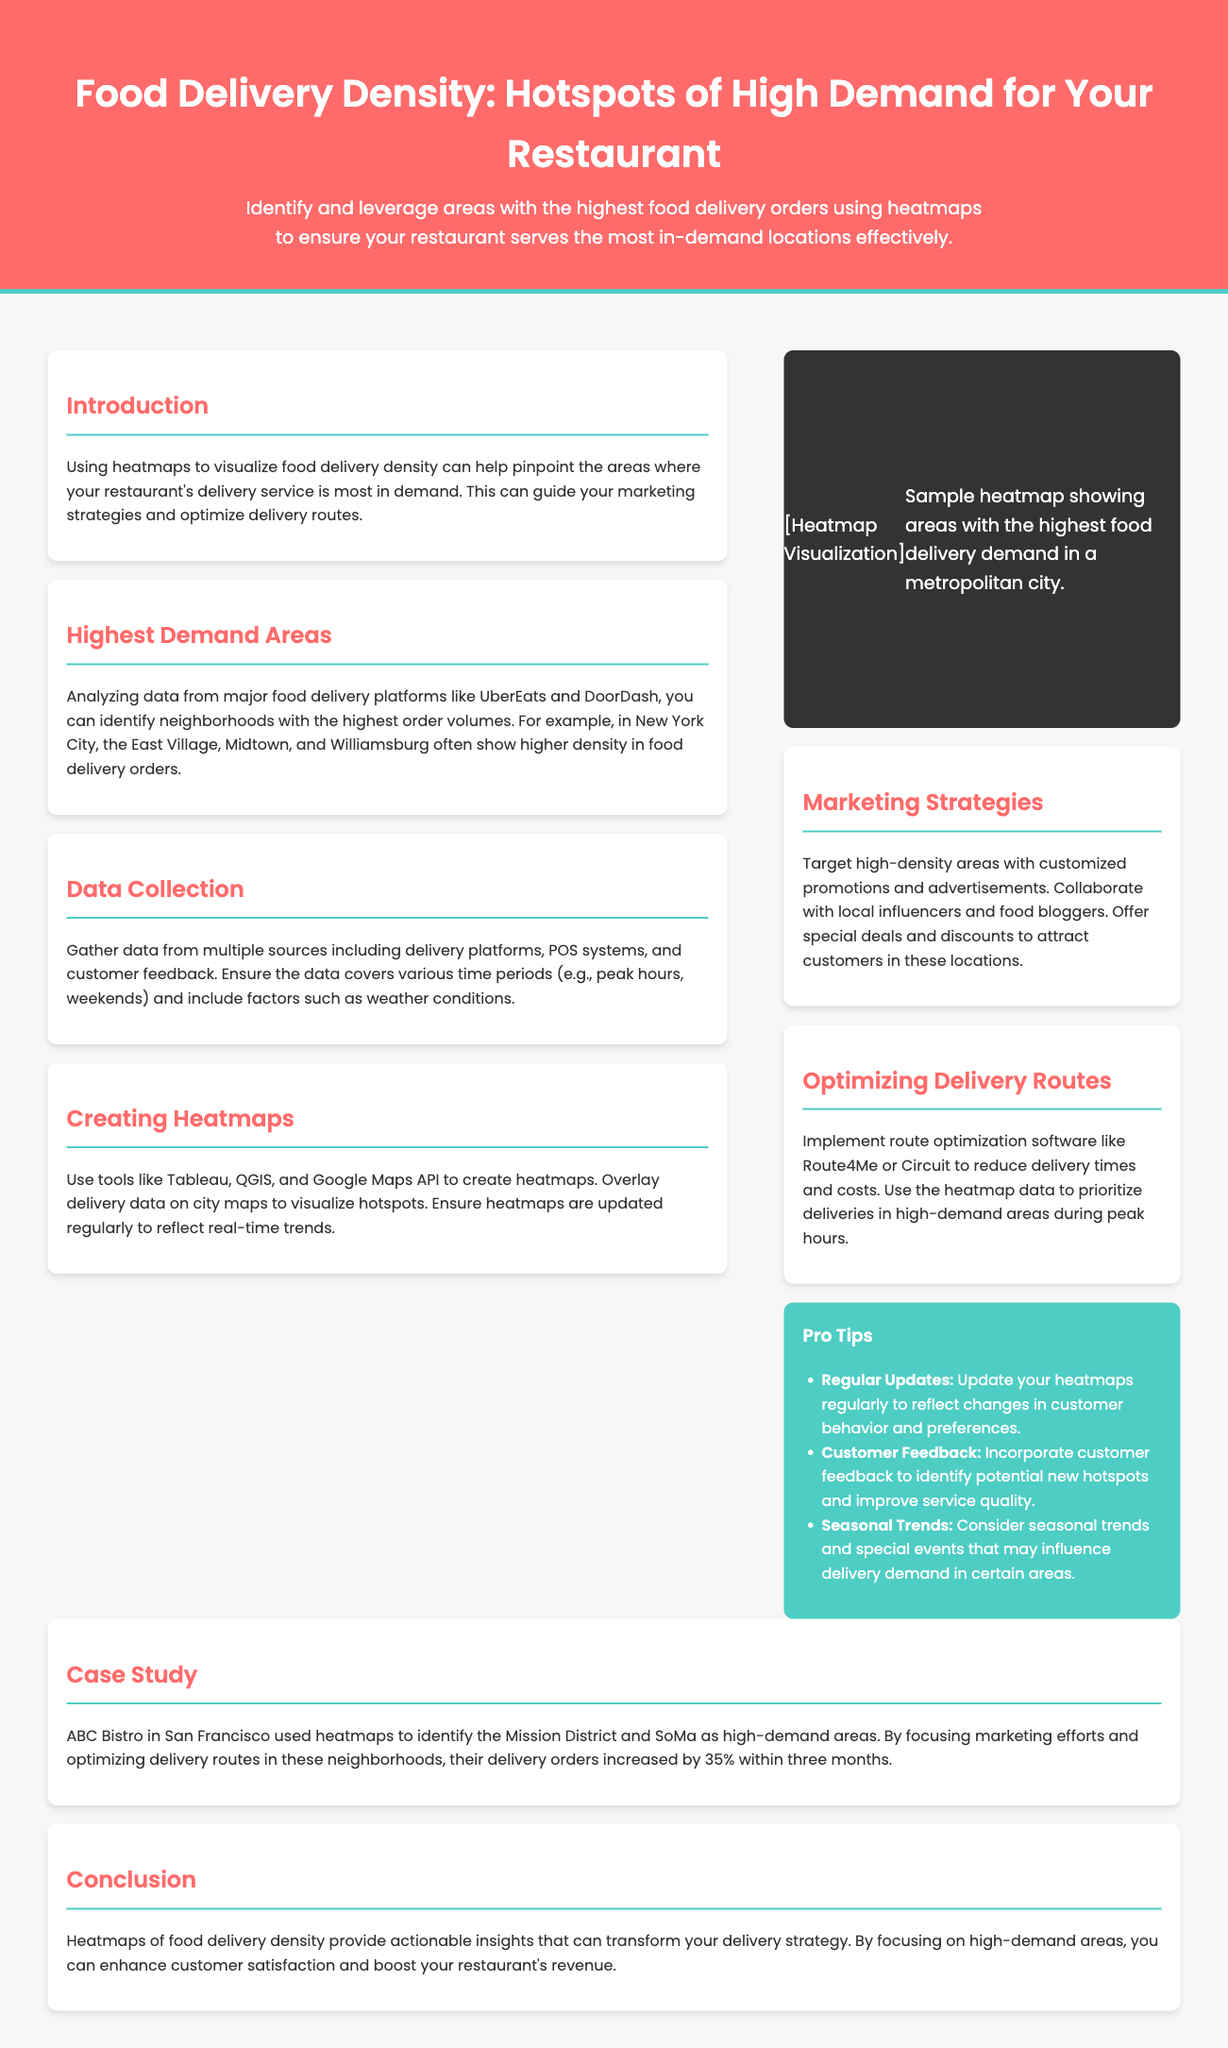What are the highest demand areas mentioned? The document states that in New York City, the East Village, Midtown, and Williamsburg are recorded as areas with high food delivery orders.
Answer: East Village, Midtown, Williamsburg What should be used to optimize delivery routes? The document recommends using route optimization software like Route4Me or Circuit to enhance delivery efficiency.
Answer: Route4Me, Circuit What is the primary purpose of using heatmaps in this context? Heatmaps are utilized to visualize food delivery density and pinpoint areas with high demand for delivery services.
Answer: Visualize food delivery density What was the increase in delivery orders for ABC Bistro? According to the case study, ABC Bistro experienced a 35% increase in delivery orders after applying the heatmap strategy.
Answer: 35% What is a recommended source of data for creating heatmaps? The document mentions gathering data from delivery platforms, POS systems, and customer feedback as key sources.
Answer: Delivery platforms, POS systems, customer feedback What color is emphasized in the header of the infographic? The header background color is primarily a shade of red, specifically #FF6B6B.
Answer: Red What type of data should be collected to understand delivery demand better? It is recommended to include various time periods like peak hours and weekends when collecting data on delivery demand.
Answer: Various time periods What strategy is suggested to target high-density delivery areas? The document recommends creating customized promotions and advertisements to attract customers in high-density areas.
Answer: Customized promotions and advertisements 